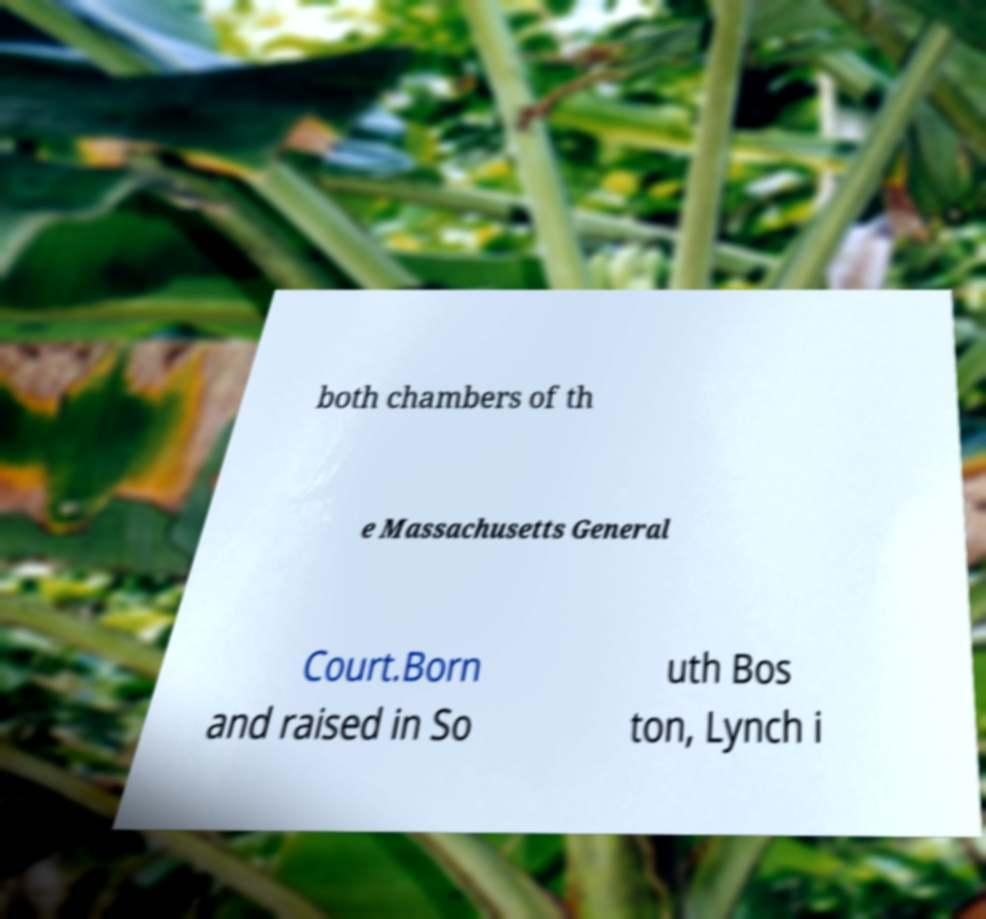Can you accurately transcribe the text from the provided image for me? both chambers of th e Massachusetts General Court.Born and raised in So uth Bos ton, Lynch i 